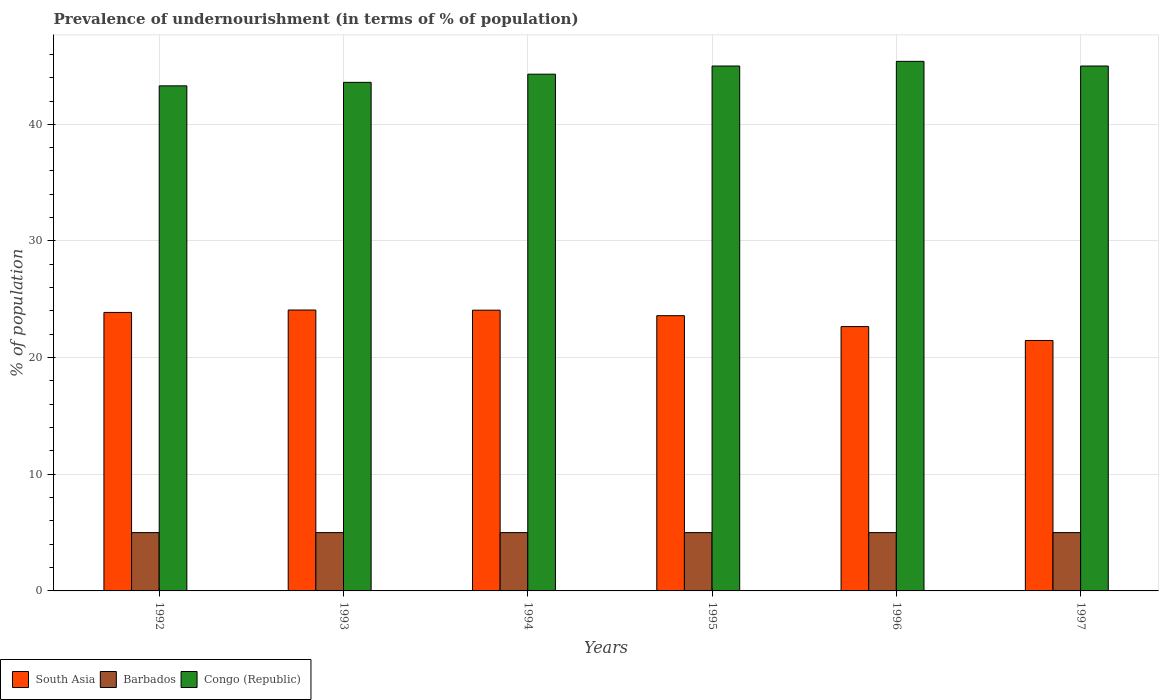How many different coloured bars are there?
Offer a very short reply. 3. How many groups of bars are there?
Give a very brief answer. 6. Are the number of bars per tick equal to the number of legend labels?
Keep it short and to the point. Yes. How many bars are there on the 3rd tick from the left?
Offer a very short reply. 3. In how many cases, is the number of bars for a given year not equal to the number of legend labels?
Your answer should be compact. 0. What is the percentage of undernourished population in South Asia in 1997?
Make the answer very short. 21.47. Across all years, what is the maximum percentage of undernourished population in Congo (Republic)?
Ensure brevity in your answer.  45.4. Across all years, what is the minimum percentage of undernourished population in Barbados?
Provide a short and direct response. 5. What is the total percentage of undernourished population in Barbados in the graph?
Make the answer very short. 30. What is the difference between the percentage of undernourished population in Congo (Republic) in 1992 and that in 1996?
Your answer should be very brief. -2.1. What is the difference between the percentage of undernourished population in South Asia in 1997 and the percentage of undernourished population in Barbados in 1994?
Offer a very short reply. 16.47. What is the average percentage of undernourished population in Congo (Republic) per year?
Keep it short and to the point. 44.43. In the year 1994, what is the difference between the percentage of undernourished population in Congo (Republic) and percentage of undernourished population in South Asia?
Your answer should be very brief. 20.23. In how many years, is the percentage of undernourished population in Congo (Republic) greater than 28 %?
Keep it short and to the point. 6. What is the ratio of the percentage of undernourished population in South Asia in 1996 to that in 1997?
Your answer should be very brief. 1.06. What is the difference between the highest and the lowest percentage of undernourished population in Congo (Republic)?
Your answer should be compact. 2.1. In how many years, is the percentage of undernourished population in Barbados greater than the average percentage of undernourished population in Barbados taken over all years?
Provide a short and direct response. 0. Is the sum of the percentage of undernourished population in South Asia in 1994 and 1997 greater than the maximum percentage of undernourished population in Barbados across all years?
Provide a short and direct response. Yes. What does the 2nd bar from the left in 1997 represents?
Provide a succinct answer. Barbados. What does the 1st bar from the right in 1997 represents?
Keep it short and to the point. Congo (Republic). How many bars are there?
Make the answer very short. 18. Are all the bars in the graph horizontal?
Your answer should be compact. No. How many years are there in the graph?
Offer a very short reply. 6. Are the values on the major ticks of Y-axis written in scientific E-notation?
Give a very brief answer. No. Does the graph contain any zero values?
Make the answer very short. No. What is the title of the graph?
Your answer should be compact. Prevalence of undernourishment (in terms of % of population). Does "Nepal" appear as one of the legend labels in the graph?
Your answer should be compact. No. What is the label or title of the Y-axis?
Give a very brief answer. % of population. What is the % of population of South Asia in 1992?
Give a very brief answer. 23.88. What is the % of population of Congo (Republic) in 1992?
Keep it short and to the point. 43.3. What is the % of population of South Asia in 1993?
Ensure brevity in your answer.  24.08. What is the % of population of Congo (Republic) in 1993?
Keep it short and to the point. 43.6. What is the % of population of South Asia in 1994?
Give a very brief answer. 24.07. What is the % of population of Congo (Republic) in 1994?
Your response must be concise. 44.3. What is the % of population in South Asia in 1995?
Give a very brief answer. 23.6. What is the % of population of Barbados in 1995?
Provide a short and direct response. 5. What is the % of population in Congo (Republic) in 1995?
Your answer should be compact. 45. What is the % of population in South Asia in 1996?
Offer a very short reply. 22.66. What is the % of population of Barbados in 1996?
Provide a succinct answer. 5. What is the % of population in Congo (Republic) in 1996?
Offer a very short reply. 45.4. What is the % of population of South Asia in 1997?
Provide a succinct answer. 21.47. What is the % of population in Barbados in 1997?
Your answer should be compact. 5. What is the % of population in Congo (Republic) in 1997?
Give a very brief answer. 45. Across all years, what is the maximum % of population in South Asia?
Offer a terse response. 24.08. Across all years, what is the maximum % of population of Congo (Republic)?
Offer a very short reply. 45.4. Across all years, what is the minimum % of population in South Asia?
Provide a short and direct response. 21.47. Across all years, what is the minimum % of population of Congo (Republic)?
Your answer should be compact. 43.3. What is the total % of population of South Asia in the graph?
Provide a succinct answer. 139.75. What is the total % of population in Congo (Republic) in the graph?
Make the answer very short. 266.6. What is the difference between the % of population in South Asia in 1992 and that in 1993?
Offer a very short reply. -0.21. What is the difference between the % of population in South Asia in 1992 and that in 1994?
Offer a very short reply. -0.19. What is the difference between the % of population in Congo (Republic) in 1992 and that in 1994?
Make the answer very short. -1. What is the difference between the % of population of South Asia in 1992 and that in 1995?
Make the answer very short. 0.28. What is the difference between the % of population of Congo (Republic) in 1992 and that in 1995?
Provide a succinct answer. -1.7. What is the difference between the % of population in South Asia in 1992 and that in 1996?
Provide a succinct answer. 1.21. What is the difference between the % of population in Congo (Republic) in 1992 and that in 1996?
Give a very brief answer. -2.1. What is the difference between the % of population of South Asia in 1992 and that in 1997?
Give a very brief answer. 2.4. What is the difference between the % of population in Congo (Republic) in 1992 and that in 1997?
Your answer should be compact. -1.7. What is the difference between the % of population in South Asia in 1993 and that in 1994?
Offer a very short reply. 0.01. What is the difference between the % of population in Barbados in 1993 and that in 1994?
Keep it short and to the point. 0. What is the difference between the % of population of South Asia in 1993 and that in 1995?
Give a very brief answer. 0.49. What is the difference between the % of population of Barbados in 1993 and that in 1995?
Your answer should be very brief. 0. What is the difference between the % of population of Congo (Republic) in 1993 and that in 1995?
Provide a succinct answer. -1.4. What is the difference between the % of population of South Asia in 1993 and that in 1996?
Your answer should be compact. 1.42. What is the difference between the % of population of Barbados in 1993 and that in 1996?
Keep it short and to the point. 0. What is the difference between the % of population in Congo (Republic) in 1993 and that in 1996?
Make the answer very short. -1.8. What is the difference between the % of population of South Asia in 1993 and that in 1997?
Your answer should be very brief. 2.61. What is the difference between the % of population of Congo (Republic) in 1993 and that in 1997?
Your answer should be very brief. -1.4. What is the difference between the % of population of South Asia in 1994 and that in 1995?
Ensure brevity in your answer.  0.47. What is the difference between the % of population in South Asia in 1994 and that in 1996?
Offer a very short reply. 1.41. What is the difference between the % of population in South Asia in 1994 and that in 1997?
Make the answer very short. 2.6. What is the difference between the % of population in South Asia in 1995 and that in 1996?
Your answer should be compact. 0.93. What is the difference between the % of population in South Asia in 1995 and that in 1997?
Provide a short and direct response. 2.12. What is the difference between the % of population of Barbados in 1995 and that in 1997?
Offer a terse response. 0. What is the difference between the % of population of Congo (Republic) in 1995 and that in 1997?
Offer a terse response. 0. What is the difference between the % of population of South Asia in 1996 and that in 1997?
Keep it short and to the point. 1.19. What is the difference between the % of population in Barbados in 1996 and that in 1997?
Your response must be concise. 0. What is the difference between the % of population of South Asia in 1992 and the % of population of Barbados in 1993?
Provide a short and direct response. 18.88. What is the difference between the % of population of South Asia in 1992 and the % of population of Congo (Republic) in 1993?
Provide a succinct answer. -19.72. What is the difference between the % of population in Barbados in 1992 and the % of population in Congo (Republic) in 1993?
Your answer should be very brief. -38.6. What is the difference between the % of population of South Asia in 1992 and the % of population of Barbados in 1994?
Your answer should be compact. 18.88. What is the difference between the % of population of South Asia in 1992 and the % of population of Congo (Republic) in 1994?
Ensure brevity in your answer.  -20.42. What is the difference between the % of population in Barbados in 1992 and the % of population in Congo (Republic) in 1994?
Ensure brevity in your answer.  -39.3. What is the difference between the % of population of South Asia in 1992 and the % of population of Barbados in 1995?
Make the answer very short. 18.88. What is the difference between the % of population in South Asia in 1992 and the % of population in Congo (Republic) in 1995?
Provide a short and direct response. -21.12. What is the difference between the % of population in Barbados in 1992 and the % of population in Congo (Republic) in 1995?
Your response must be concise. -40. What is the difference between the % of population of South Asia in 1992 and the % of population of Barbados in 1996?
Your answer should be compact. 18.88. What is the difference between the % of population in South Asia in 1992 and the % of population in Congo (Republic) in 1996?
Keep it short and to the point. -21.52. What is the difference between the % of population in Barbados in 1992 and the % of population in Congo (Republic) in 1996?
Offer a terse response. -40.4. What is the difference between the % of population in South Asia in 1992 and the % of population in Barbados in 1997?
Offer a very short reply. 18.88. What is the difference between the % of population of South Asia in 1992 and the % of population of Congo (Republic) in 1997?
Give a very brief answer. -21.12. What is the difference between the % of population of Barbados in 1992 and the % of population of Congo (Republic) in 1997?
Your answer should be very brief. -40. What is the difference between the % of population in South Asia in 1993 and the % of population in Barbados in 1994?
Provide a succinct answer. 19.08. What is the difference between the % of population in South Asia in 1993 and the % of population in Congo (Republic) in 1994?
Keep it short and to the point. -20.22. What is the difference between the % of population in Barbados in 1993 and the % of population in Congo (Republic) in 1994?
Keep it short and to the point. -39.3. What is the difference between the % of population of South Asia in 1993 and the % of population of Barbados in 1995?
Make the answer very short. 19.08. What is the difference between the % of population in South Asia in 1993 and the % of population in Congo (Republic) in 1995?
Your response must be concise. -20.92. What is the difference between the % of population in South Asia in 1993 and the % of population in Barbados in 1996?
Your answer should be very brief. 19.08. What is the difference between the % of population in South Asia in 1993 and the % of population in Congo (Republic) in 1996?
Offer a very short reply. -21.32. What is the difference between the % of population in Barbados in 1993 and the % of population in Congo (Republic) in 1996?
Make the answer very short. -40.4. What is the difference between the % of population of South Asia in 1993 and the % of population of Barbados in 1997?
Ensure brevity in your answer.  19.08. What is the difference between the % of population in South Asia in 1993 and the % of population in Congo (Republic) in 1997?
Your answer should be compact. -20.92. What is the difference between the % of population in Barbados in 1993 and the % of population in Congo (Republic) in 1997?
Your response must be concise. -40. What is the difference between the % of population in South Asia in 1994 and the % of population in Barbados in 1995?
Your response must be concise. 19.07. What is the difference between the % of population in South Asia in 1994 and the % of population in Congo (Republic) in 1995?
Provide a short and direct response. -20.93. What is the difference between the % of population of South Asia in 1994 and the % of population of Barbados in 1996?
Provide a succinct answer. 19.07. What is the difference between the % of population of South Asia in 1994 and the % of population of Congo (Republic) in 1996?
Give a very brief answer. -21.33. What is the difference between the % of population in Barbados in 1994 and the % of population in Congo (Republic) in 1996?
Offer a very short reply. -40.4. What is the difference between the % of population of South Asia in 1994 and the % of population of Barbados in 1997?
Your answer should be very brief. 19.07. What is the difference between the % of population in South Asia in 1994 and the % of population in Congo (Republic) in 1997?
Provide a succinct answer. -20.93. What is the difference between the % of population in South Asia in 1995 and the % of population in Barbados in 1996?
Offer a terse response. 18.6. What is the difference between the % of population of South Asia in 1995 and the % of population of Congo (Republic) in 1996?
Provide a succinct answer. -21.8. What is the difference between the % of population of Barbados in 1995 and the % of population of Congo (Republic) in 1996?
Ensure brevity in your answer.  -40.4. What is the difference between the % of population of South Asia in 1995 and the % of population of Barbados in 1997?
Provide a succinct answer. 18.6. What is the difference between the % of population in South Asia in 1995 and the % of population in Congo (Republic) in 1997?
Provide a short and direct response. -21.4. What is the difference between the % of population of South Asia in 1996 and the % of population of Barbados in 1997?
Ensure brevity in your answer.  17.66. What is the difference between the % of population in South Asia in 1996 and the % of population in Congo (Republic) in 1997?
Make the answer very short. -22.34. What is the difference between the % of population in Barbados in 1996 and the % of population in Congo (Republic) in 1997?
Your answer should be very brief. -40. What is the average % of population of South Asia per year?
Offer a very short reply. 23.29. What is the average % of population of Congo (Republic) per year?
Provide a short and direct response. 44.43. In the year 1992, what is the difference between the % of population of South Asia and % of population of Barbados?
Your answer should be compact. 18.88. In the year 1992, what is the difference between the % of population of South Asia and % of population of Congo (Republic)?
Provide a succinct answer. -19.42. In the year 1992, what is the difference between the % of population of Barbados and % of population of Congo (Republic)?
Provide a short and direct response. -38.3. In the year 1993, what is the difference between the % of population of South Asia and % of population of Barbados?
Your answer should be compact. 19.08. In the year 1993, what is the difference between the % of population of South Asia and % of population of Congo (Republic)?
Your answer should be very brief. -19.52. In the year 1993, what is the difference between the % of population of Barbados and % of population of Congo (Republic)?
Provide a short and direct response. -38.6. In the year 1994, what is the difference between the % of population of South Asia and % of population of Barbados?
Ensure brevity in your answer.  19.07. In the year 1994, what is the difference between the % of population of South Asia and % of population of Congo (Republic)?
Ensure brevity in your answer.  -20.23. In the year 1994, what is the difference between the % of population of Barbados and % of population of Congo (Republic)?
Your response must be concise. -39.3. In the year 1995, what is the difference between the % of population in South Asia and % of population in Barbados?
Your answer should be compact. 18.6. In the year 1995, what is the difference between the % of population in South Asia and % of population in Congo (Republic)?
Your answer should be very brief. -21.4. In the year 1996, what is the difference between the % of population in South Asia and % of population in Barbados?
Offer a very short reply. 17.66. In the year 1996, what is the difference between the % of population in South Asia and % of population in Congo (Republic)?
Keep it short and to the point. -22.74. In the year 1996, what is the difference between the % of population in Barbados and % of population in Congo (Republic)?
Your response must be concise. -40.4. In the year 1997, what is the difference between the % of population of South Asia and % of population of Barbados?
Provide a short and direct response. 16.47. In the year 1997, what is the difference between the % of population of South Asia and % of population of Congo (Republic)?
Ensure brevity in your answer.  -23.53. In the year 1997, what is the difference between the % of population of Barbados and % of population of Congo (Republic)?
Keep it short and to the point. -40. What is the ratio of the % of population of Barbados in 1992 to that in 1993?
Offer a terse response. 1. What is the ratio of the % of population of Congo (Republic) in 1992 to that in 1993?
Provide a short and direct response. 0.99. What is the ratio of the % of population of South Asia in 1992 to that in 1994?
Offer a terse response. 0.99. What is the ratio of the % of population in Congo (Republic) in 1992 to that in 1994?
Your answer should be very brief. 0.98. What is the ratio of the % of population of South Asia in 1992 to that in 1995?
Provide a succinct answer. 1.01. What is the ratio of the % of population in Barbados in 1992 to that in 1995?
Your answer should be very brief. 1. What is the ratio of the % of population in Congo (Republic) in 1992 to that in 1995?
Ensure brevity in your answer.  0.96. What is the ratio of the % of population in South Asia in 1992 to that in 1996?
Keep it short and to the point. 1.05. What is the ratio of the % of population of Barbados in 1992 to that in 1996?
Your answer should be very brief. 1. What is the ratio of the % of population in Congo (Republic) in 1992 to that in 1996?
Provide a short and direct response. 0.95. What is the ratio of the % of population of South Asia in 1992 to that in 1997?
Provide a short and direct response. 1.11. What is the ratio of the % of population of Barbados in 1992 to that in 1997?
Offer a terse response. 1. What is the ratio of the % of population of Congo (Republic) in 1992 to that in 1997?
Your answer should be compact. 0.96. What is the ratio of the % of population in Congo (Republic) in 1993 to that in 1994?
Your answer should be compact. 0.98. What is the ratio of the % of population in South Asia in 1993 to that in 1995?
Make the answer very short. 1.02. What is the ratio of the % of population in Barbados in 1993 to that in 1995?
Your answer should be compact. 1. What is the ratio of the % of population of Congo (Republic) in 1993 to that in 1995?
Give a very brief answer. 0.97. What is the ratio of the % of population in South Asia in 1993 to that in 1996?
Your answer should be very brief. 1.06. What is the ratio of the % of population of Barbados in 1993 to that in 1996?
Your answer should be compact. 1. What is the ratio of the % of population of Congo (Republic) in 1993 to that in 1996?
Your answer should be very brief. 0.96. What is the ratio of the % of population in South Asia in 1993 to that in 1997?
Offer a terse response. 1.12. What is the ratio of the % of population of Congo (Republic) in 1993 to that in 1997?
Give a very brief answer. 0.97. What is the ratio of the % of population in South Asia in 1994 to that in 1995?
Offer a terse response. 1.02. What is the ratio of the % of population in Congo (Republic) in 1994 to that in 1995?
Give a very brief answer. 0.98. What is the ratio of the % of population in South Asia in 1994 to that in 1996?
Provide a succinct answer. 1.06. What is the ratio of the % of population of Barbados in 1994 to that in 1996?
Offer a terse response. 1. What is the ratio of the % of population of Congo (Republic) in 1994 to that in 1996?
Make the answer very short. 0.98. What is the ratio of the % of population in South Asia in 1994 to that in 1997?
Ensure brevity in your answer.  1.12. What is the ratio of the % of population in Barbados in 1994 to that in 1997?
Your answer should be very brief. 1. What is the ratio of the % of population of Congo (Republic) in 1994 to that in 1997?
Make the answer very short. 0.98. What is the ratio of the % of population of South Asia in 1995 to that in 1996?
Your response must be concise. 1.04. What is the ratio of the % of population in Barbados in 1995 to that in 1996?
Give a very brief answer. 1. What is the ratio of the % of population in South Asia in 1995 to that in 1997?
Make the answer very short. 1.1. What is the ratio of the % of population of South Asia in 1996 to that in 1997?
Offer a very short reply. 1.06. What is the ratio of the % of population in Barbados in 1996 to that in 1997?
Keep it short and to the point. 1. What is the ratio of the % of population in Congo (Republic) in 1996 to that in 1997?
Keep it short and to the point. 1.01. What is the difference between the highest and the second highest % of population in South Asia?
Offer a very short reply. 0.01. What is the difference between the highest and the second highest % of population in Congo (Republic)?
Your response must be concise. 0.4. What is the difference between the highest and the lowest % of population of South Asia?
Provide a short and direct response. 2.61. What is the difference between the highest and the lowest % of population of Barbados?
Offer a terse response. 0. 